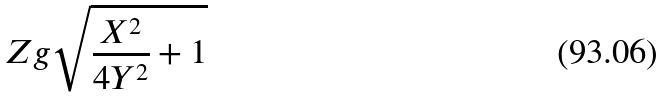<formula> <loc_0><loc_0><loc_500><loc_500>Z g \sqrt { \frac { X ^ { 2 } } { 4 Y ^ { 2 } } + 1 }</formula> 